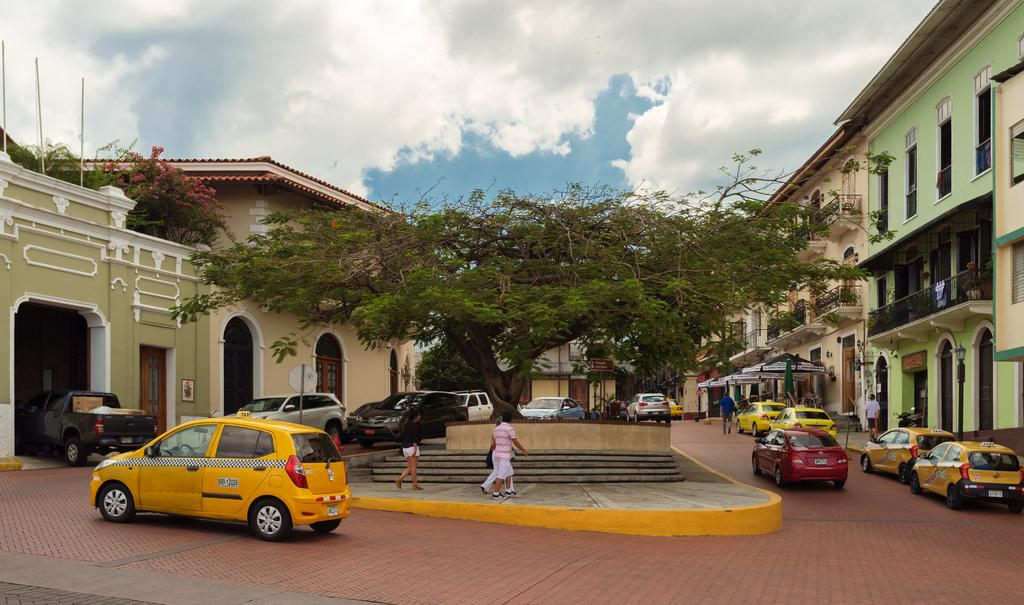Who or what can be seen in the image? There are people in the image. What else is present in the image besides people? There are vehicles, trees, houses, and windows in the image. Can you describe the setting of the image? The image features houses, trees, and vehicles, suggesting it is a residential or urban area. What is the condition of the sky in the image? The sky is visible and appears cloudy in the image. Where is the poison located in the image? There is no poison present in the image. What type of growth can be seen on the trees in the image? There is no specific growth mentioned or visible in the image; only trees are present. 